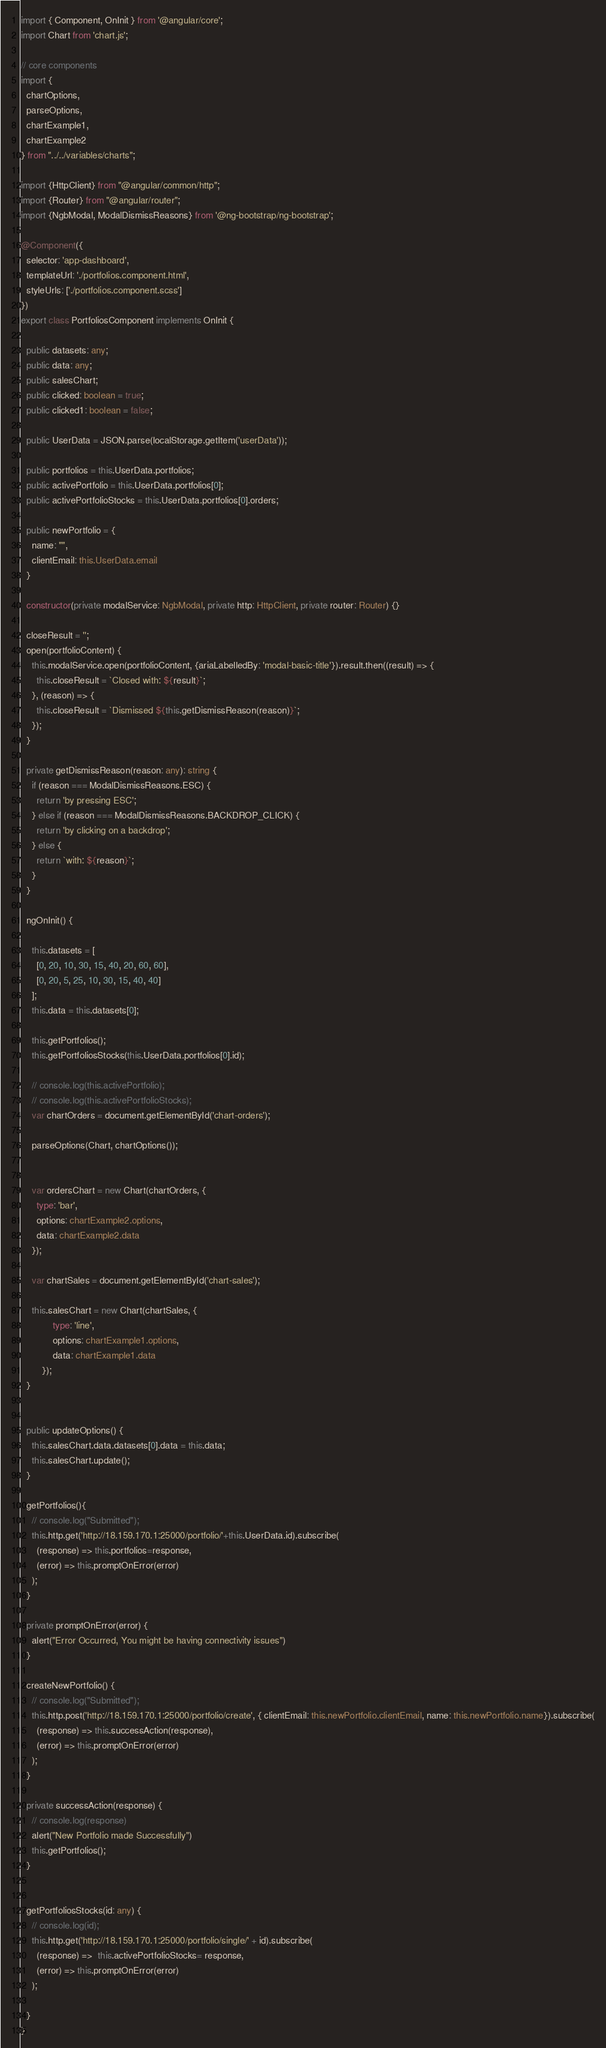<code> <loc_0><loc_0><loc_500><loc_500><_TypeScript_>import { Component, OnInit } from '@angular/core';
import Chart from 'chart.js';

// core components
import {
  chartOptions,
  parseOptions,
  chartExample1,
  chartExample2
} from "../../variables/charts";

import {HttpClient} from "@angular/common/http";
import {Router} from "@angular/router";
import {NgbModal, ModalDismissReasons} from '@ng-bootstrap/ng-bootstrap';

@Component({
  selector: 'app-dashboard',
  templateUrl: './portfolios.component.html',
  styleUrls: ['./portfolios.component.scss']
})
export class PortfoliosComponent implements OnInit {

  public datasets: any;
  public data: any;
  public salesChart;
  public clicked: boolean = true;
  public clicked1: boolean = false;

  public UserData = JSON.parse(localStorage.getItem('userData'));

  public portfolios = this.UserData.portfolios;
  public activePortfolio = this.UserData.portfolios[0];
  public activePortfolioStocks = this.UserData.portfolios[0].orders;

  public newPortfolio = {
    name: "",
    clientEmail: this.UserData.email
  }

  constructor(private modalService: NgbModal, private http: HttpClient, private router: Router) {}

  closeResult = '';
  open(portfolioContent) {
    this.modalService.open(portfolioContent, {ariaLabelledBy: 'modal-basic-title'}).result.then((result) => {
      this.closeResult = `Closed with: ${result}`;
    }, (reason) => {
      this.closeResult = `Dismissed ${this.getDismissReason(reason)}`;
    });
  }

  private getDismissReason(reason: any): string {
    if (reason === ModalDismissReasons.ESC) {
      return 'by pressing ESC';
    } else if (reason === ModalDismissReasons.BACKDROP_CLICK) {
      return 'by clicking on a backdrop';
    } else {
      return `with: ${reason}`;
    }
  }

  ngOnInit() {

    this.datasets = [
      [0, 20, 10, 30, 15, 40, 20, 60, 60],
      [0, 20, 5, 25, 10, 30, 15, 40, 40]
    ];
    this.data = this.datasets[0];

    this.getPortfolios();
    this.getPortfoliosStocks(this.UserData.portfolios[0].id);

    // console.log(this.activePortfolio);
    // console.log(this.activePortfolioStocks);
    var chartOrders = document.getElementById('chart-orders');

    parseOptions(Chart, chartOptions());


    var ordersChart = new Chart(chartOrders, {
      type: 'bar',
      options: chartExample2.options,
      data: chartExample2.data
    });

    var chartSales = document.getElementById('chart-sales');

    this.salesChart = new Chart(chartSales, {
			type: 'line',
			options: chartExample1.options,
			data: chartExample1.data
		});
  }


  public updateOptions() {
    this.salesChart.data.datasets[0].data = this.data;
    this.salesChart.update();
  }

  getPortfolios(){
    // console.log("Submitted");
    this.http.get('http://18.159.170.1:25000/portfolio/'+this.UserData.id).subscribe(
      (response) => this.portfolios=response,
      (error) => this.promptOnError(error)
    );
  }

  private promptOnError(error) {
    alert("Error Occurred, You might be having connectivity issues")
  }

  createNewPortfolio() {
    // console.log("Submitted");
    this.http.post('http://18.159.170.1:25000/portfolio/create', { clientEmail: this.newPortfolio.clientEmail, name: this.newPortfolio.name}).subscribe(
      (response) => this.successAction(response),
      (error) => this.promptOnError(error)
    );
  }

  private successAction(response) {
    // console.log(response)
    alert("New Portfolio made Successfully")
    this.getPortfolios();
  }


  getPortfoliosStocks(id: any) {
    // console.log(id);
    this.http.get('http://18.159.170.1:25000/portfolio/single/' + id).subscribe(
      (response) =>  this.activePortfolioStocks= response,
      (error) => this.promptOnError(error)
    );

  }
}
</code> 